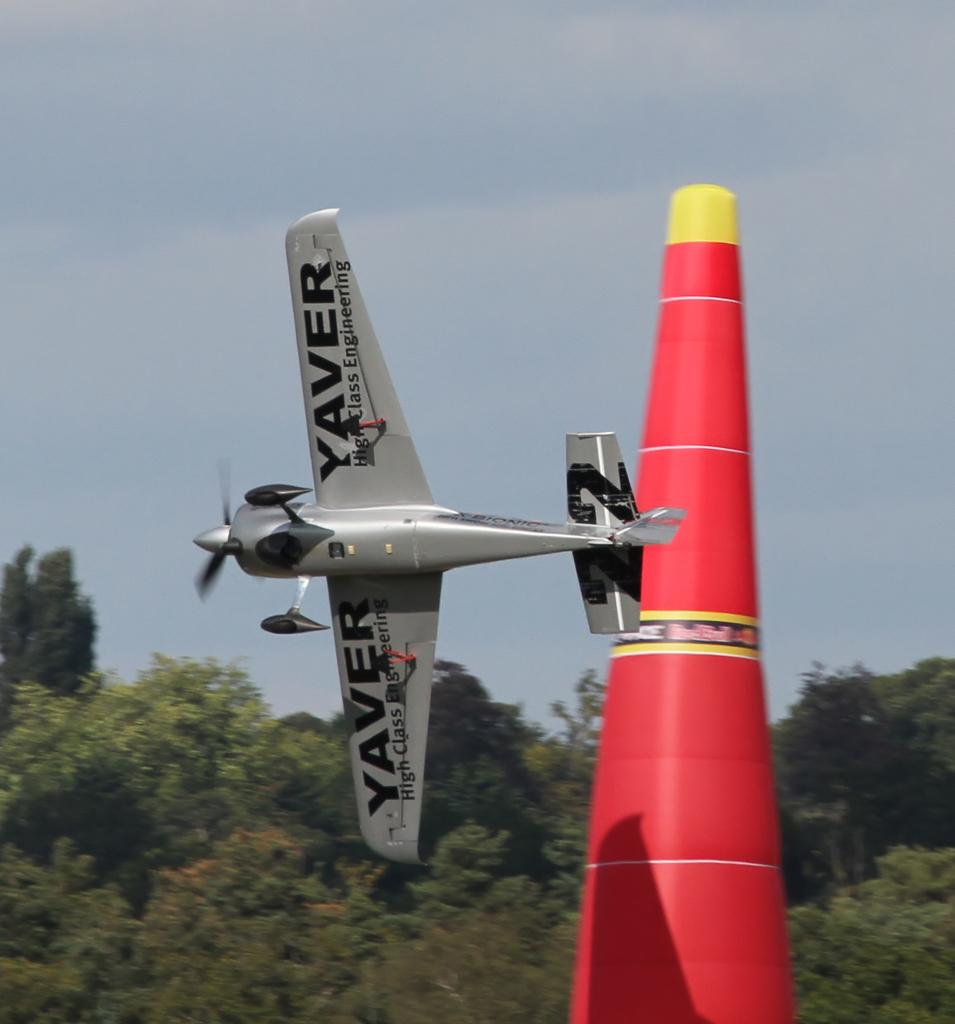<image>
Offer a succinct explanation of the picture presented. A model airplane designed by Yaver High Class Engineering is number 22. 